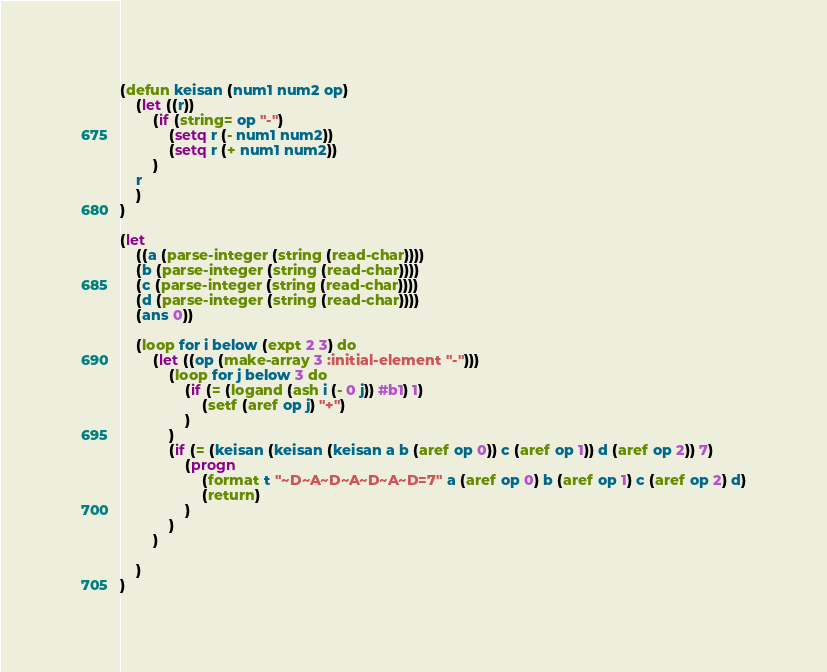Convert code to text. <code><loc_0><loc_0><loc_500><loc_500><_Lisp_>(defun keisan (num1 num2 op)
    (let ((r))
        (if (string= op "-")
            (setq r (- num1 num2))
            (setq r (+ num1 num2))
        )
    r
    )
)

(let
    ((a (parse-integer (string (read-char))))
    (b (parse-integer (string (read-char))))
    (c (parse-integer (string (read-char))))
    (d (parse-integer (string (read-char))))
    (ans 0))

    (loop for i below (expt 2 3) do
        (let ((op (make-array 3 :initial-element "-")))
            (loop for j below 3 do
                (if (= (logand (ash i (- 0 j)) #b1) 1)
                    (setf (aref op j) "+")
                )
            )
            (if (= (keisan (keisan (keisan a b (aref op 0)) c (aref op 1)) d (aref op 2)) 7)
                (progn
                    (format t "~D~A~D~A~D~A~D=7" a (aref op 0) b (aref op 1) c (aref op 2) d)
                    (return)
                )
            )
        )
        
    )
)</code> 